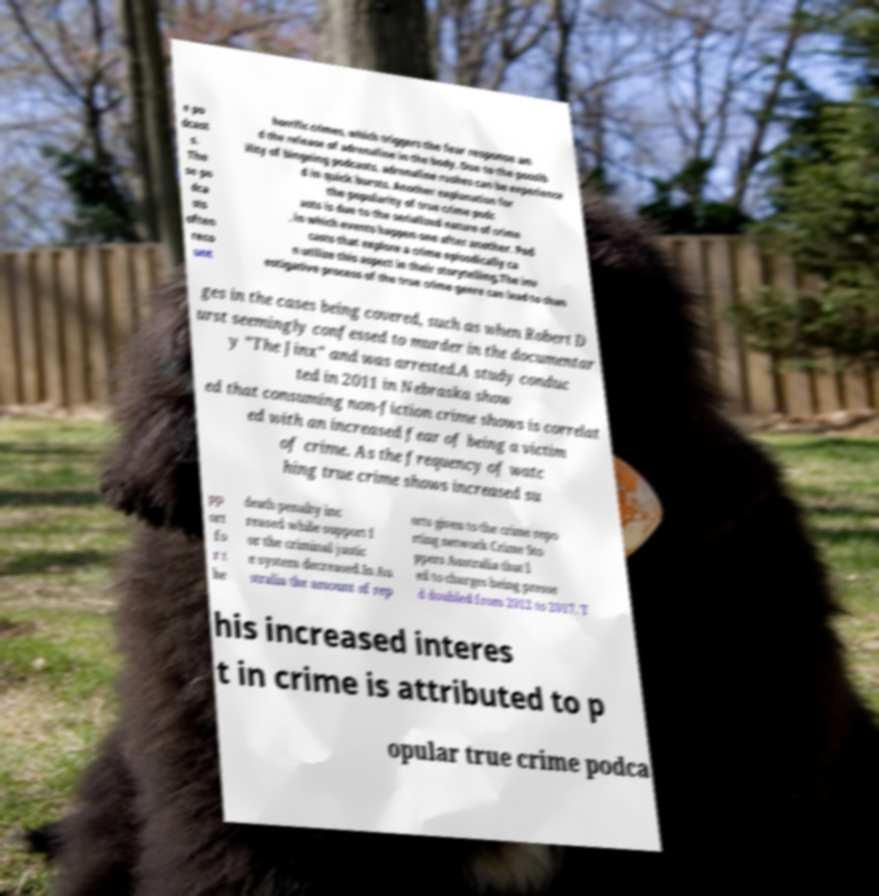Could you assist in decoding the text presented in this image and type it out clearly? e po dcast s. The se po dca sts often reco unt horrific crimes, which triggers the fear response an d the release of adrenaline in the body. Due to the possib ility of bingeing podcasts, adrenaline rushes can be experience d in quick bursts. Another explanation for the popularity of true crime podc asts is due to the serialized nature of crime , in which events happen one after another. Pod casts that explore a crime episodically ca n utilize this aspect in their storytelling.The inv estigative process of the true crime genre can lead to chan ges in the cases being covered, such as when Robert D urst seemingly confessed to murder in the documentar y "The Jinx" and was arrested.A study conduc ted in 2011 in Nebraska show ed that consuming non-fiction crime shows is correlat ed with an increased fear of being a victim of crime. As the frequency of watc hing true crime shows increased su pp ort fo r t he death penalty inc reased while support f or the criminal justic e system decreased.In Au stralia the amount of rep orts given to the crime repo rting network Crime Sto ppers Australia that l ed to charges being presse d doubled from 2012 to 2017. T his increased interes t in crime is attributed to p opular true crime podca 